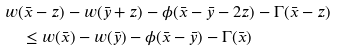<formula> <loc_0><loc_0><loc_500><loc_500>& w ( \bar { x } - z ) - w ( \bar { y } + z ) - \phi ( \bar { x } - \bar { y } - 2 z ) - \Gamma ( \bar { x } - z ) \\ & \quad \leq w ( \bar { x } ) - w ( \bar { y } ) - \phi ( \bar { x } - \bar { y } ) - \Gamma ( \bar { x } )</formula> 